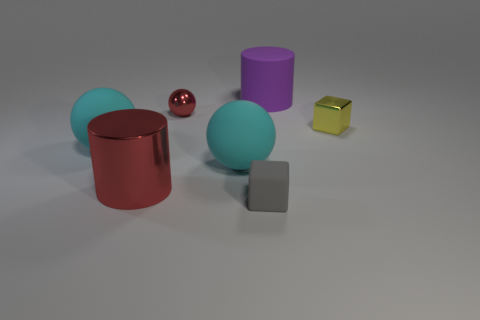There is a big metallic thing that is the same color as the small ball; what is its shape?
Your answer should be compact. Cylinder. There is a metal ball that is the same color as the large metal thing; what size is it?
Your answer should be very brief. Small. What material is the red ball?
Provide a short and direct response. Metal. What material is the cylinder in front of the tiny yellow thing?
Ensure brevity in your answer.  Metal. Are there any other things that have the same material as the big red object?
Your answer should be compact. Yes. Is the number of large rubber cylinders that are on the right side of the large purple cylinder greater than the number of large cyan matte balls?
Your answer should be very brief. No. There is a red thing right of the big cylinder on the left side of the purple matte cylinder; are there any shiny cubes that are right of it?
Make the answer very short. Yes. There is a big metal object; are there any blocks left of it?
Offer a very short reply. No. How many small spheres are the same color as the small metal block?
Give a very brief answer. 0. What is the size of the cylinder that is the same material as the yellow cube?
Your answer should be compact. Large. 